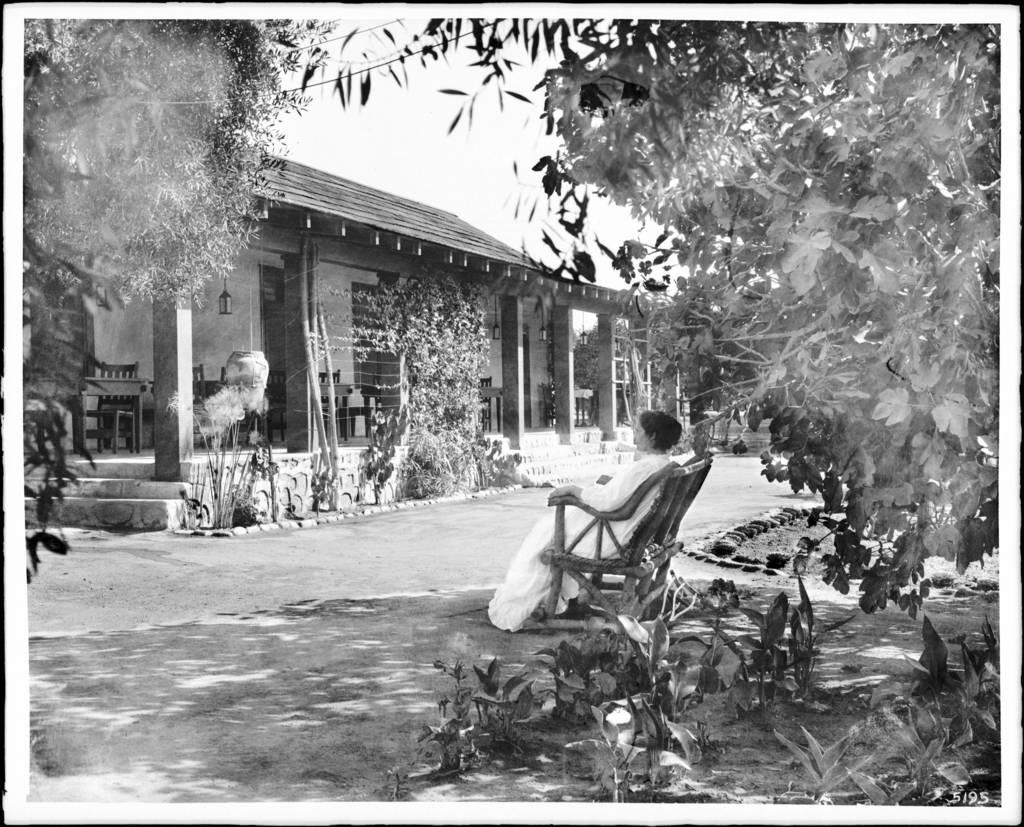What is the color scheme of the image? The image is black and white. What can be seen in the image besides the house? There is a person sitting on a chair and trees in the image. Can you describe the house in the image? The house has stairs, a lantern, tables, and chairs. What type of noise can be heard coming from the fan in the image? There is no fan present in the image, so no noise can be heard from it. Where is the mailbox located in the image? There is no mailbox visible in the image. 